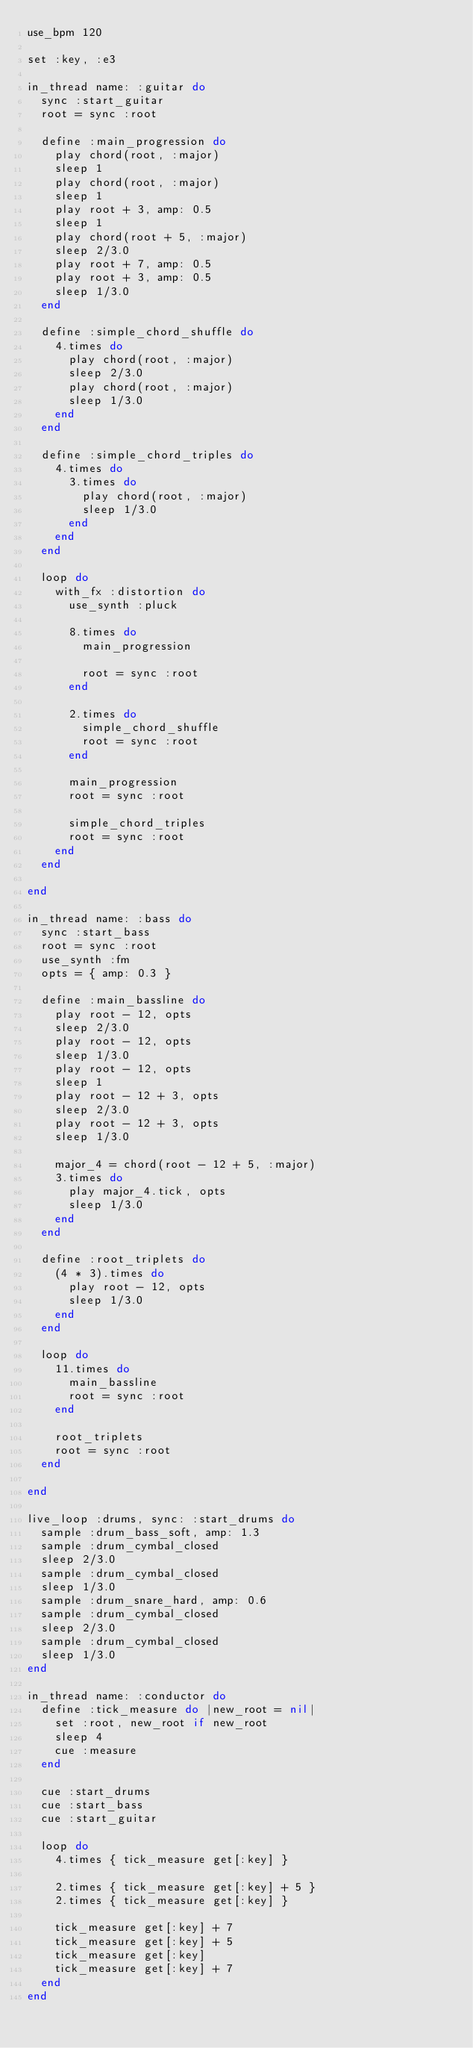<code> <loc_0><loc_0><loc_500><loc_500><_Ruby_>use_bpm 120

set :key, :e3

in_thread name: :guitar do
  sync :start_guitar
  root = sync :root
  
  define :main_progression do
    play chord(root, :major)
    sleep 1
    play chord(root, :major)
    sleep 1
    play root + 3, amp: 0.5
    sleep 1
    play chord(root + 5, :major)
    sleep 2/3.0
    play root + 7, amp: 0.5
    play root + 3, amp: 0.5
    sleep 1/3.0
  end
  
  define :simple_chord_shuffle do
    4.times do
      play chord(root, :major)
      sleep 2/3.0
      play chord(root, :major)
      sleep 1/3.0
    end
  end
  
  define :simple_chord_triples do
    4.times do
      3.times do
        play chord(root, :major)
        sleep 1/3.0
      end
    end
  end
  
  loop do
    with_fx :distortion do
      use_synth :pluck
      
      8.times do
        main_progression
        
        root = sync :root
      end
      
      2.times do
        simple_chord_shuffle
        root = sync :root
      end
      
      main_progression
      root = sync :root
      
      simple_chord_triples
      root = sync :root
    end
  end
  
end

in_thread name: :bass do
  sync :start_bass
  root = sync :root
  use_synth :fm
  opts = { amp: 0.3 }
  
  define :main_bassline do
    play root - 12, opts
    sleep 2/3.0
    play root - 12, opts
    sleep 1/3.0
    play root - 12, opts
    sleep 1
    play root - 12 + 3, opts
    sleep 2/3.0
    play root - 12 + 3, opts
    sleep 1/3.0
    
    major_4 = chord(root - 12 + 5, :major)
    3.times do
      play major_4.tick, opts
      sleep 1/3.0
    end
  end
  
  define :root_triplets do
    (4 * 3).times do
      play root - 12, opts
      sleep 1/3.0
    end
  end
  
  loop do
    11.times do
      main_bassline
      root = sync :root
    end
    
    root_triplets
    root = sync :root
  end
  
end

live_loop :drums, sync: :start_drums do
  sample :drum_bass_soft, amp: 1.3
  sample :drum_cymbal_closed
  sleep 2/3.0
  sample :drum_cymbal_closed
  sleep 1/3.0
  sample :drum_snare_hard, amp: 0.6
  sample :drum_cymbal_closed
  sleep 2/3.0
  sample :drum_cymbal_closed
  sleep 1/3.0
end

in_thread name: :conductor do
  define :tick_measure do |new_root = nil|
    set :root, new_root if new_root
    sleep 4
    cue :measure
  end
  
  cue :start_drums
  cue :start_bass
  cue :start_guitar
  
  loop do
    4.times { tick_measure get[:key] }
    
    2.times { tick_measure get[:key] + 5 }
    2.times { tick_measure get[:key] }
    
    tick_measure get[:key] + 7
    tick_measure get[:key] + 5
    tick_measure get[:key]
    tick_measure get[:key] + 7
  end
end
</code> 